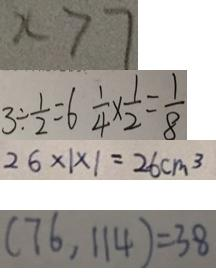<formula> <loc_0><loc_0><loc_500><loc_500>x > 7 
 3 \div \frac { 1 } { 2 } = 6 \frac { 1 } { 4 } \times \frac { 1 } { 2 } = \frac { 1 } { 8 } 
 2 6 \times 1 \times 1 = 2 6 c m ^ { 3 } 
 ( 7 6 , 1 1 4 ) = 3 8</formula> 